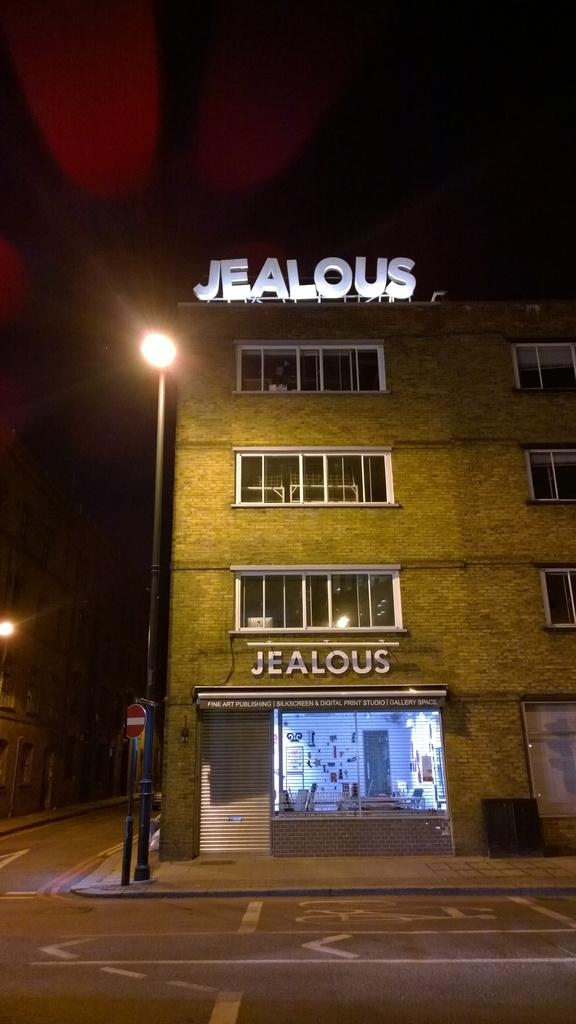What is located in the middle of the image? There is a pole, a signboard, and a building in the middle of the image. Can you describe the pole in the image? The pole is a vertical structure that stands in the middle of the image. What information does the signboard provide in the image? The signboard in the image contains text or graphics that convey information or advertising. What type of structure is the building in the image? The building in the image is a man-made structure with walls and a roof. Where is the cow sitting on the throne in the image? There is no cow or throne present in the image. 